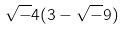<formula> <loc_0><loc_0><loc_500><loc_500>\sqrt { - } 4 ( 3 - \sqrt { - } 9 )</formula> 